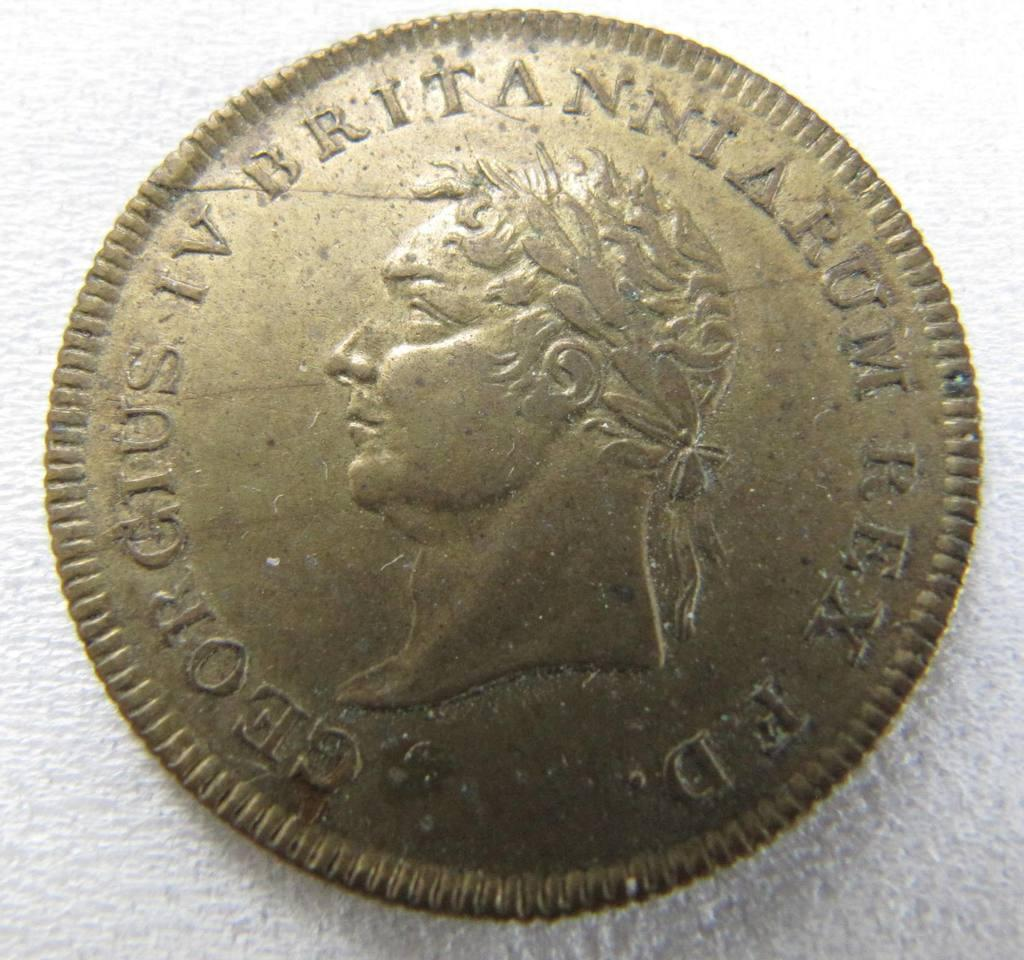What object can be seen in the image? There is a coin in the image. What type of pies are being served in the image? There are no pies present in the image; it only features a coin. What brand of soda can be seen in the image? There is no soda present in the image; it only features a coin. 